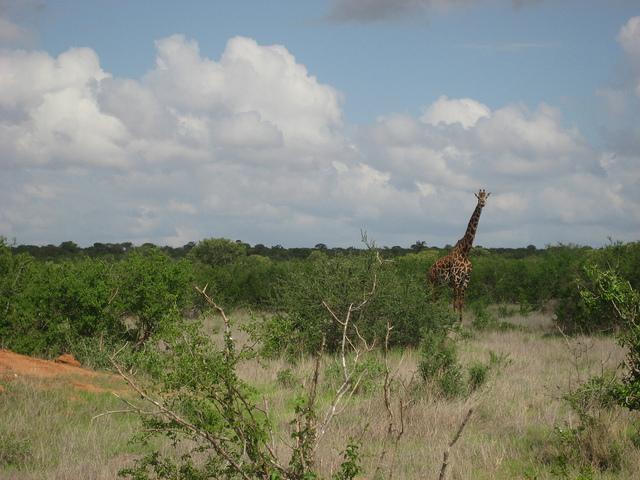What continent might this giraffe be on?
Short answer required. Africa. What kind of animal is this?
Answer briefly. Giraffe. What color are the trees?
Keep it brief. Green. Is the sky clear?
Short answer required. No. What color are the animals?
Concise answer only. Brown. Is this in a farm?
Concise answer only. No. 